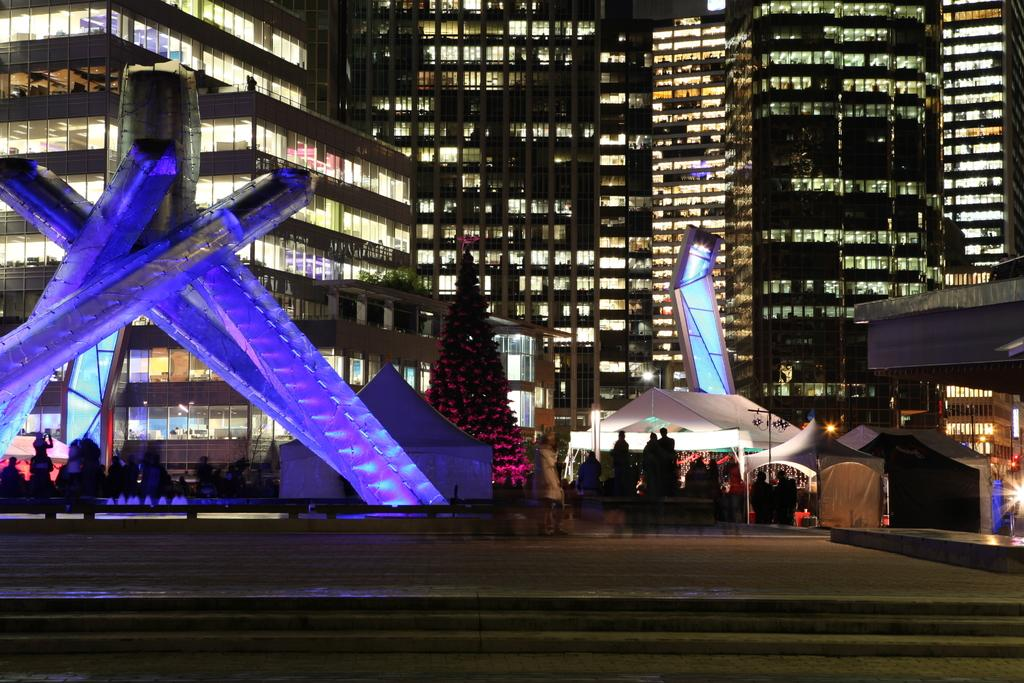What type of surface can be seen in the image? Ground is visible in the image. What architectural feature is present in the image? There are steps in the image. Who or what is present in the image? There are people in the image. What type of temporary shelter is visible in the image? There are tents in the image. What type of vegetation is present in the image? There are trees in the image. What type of illumination is present in the image? There are lights in the image. What type of permanent structures are visible in the image? There are buildings in the image. What additional objects can be seen in the image? There are some objects in the image. What type of produce is being harvested by the mother in the image? There is no mother or produce present in the image. What is the zinc content of the objects in the image? The zinc content of the objects in the image cannot be determined from the image itself. 